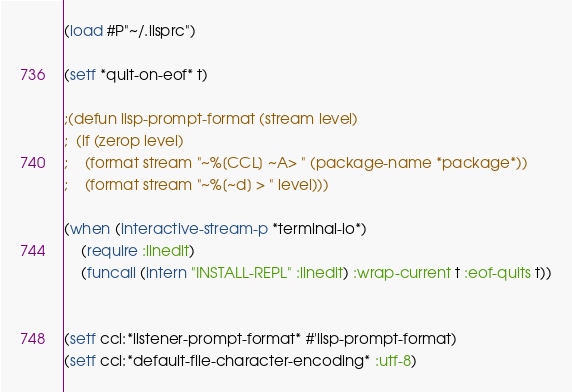<code> <loc_0><loc_0><loc_500><loc_500><_Lisp_>(load #P"~/.lisprc")

(setf *quit-on-eof* t)

;(defun lisp-prompt-format (stream level)
;  (if (zerop level)
;    (format stream "~%[CCL] ~A> " (package-name *package*))
;    (format stream "~%[~d] > " level)))

(when (interactive-stream-p *terminal-io*)
    (require :linedit)
    (funcall (intern "INSTALL-REPL" :linedit) :wrap-current t :eof-quits t))


(setf ccl:*listener-prompt-format* #'lisp-prompt-format)
(setf ccl:*default-file-character-encoding* :utf-8)
</code> 